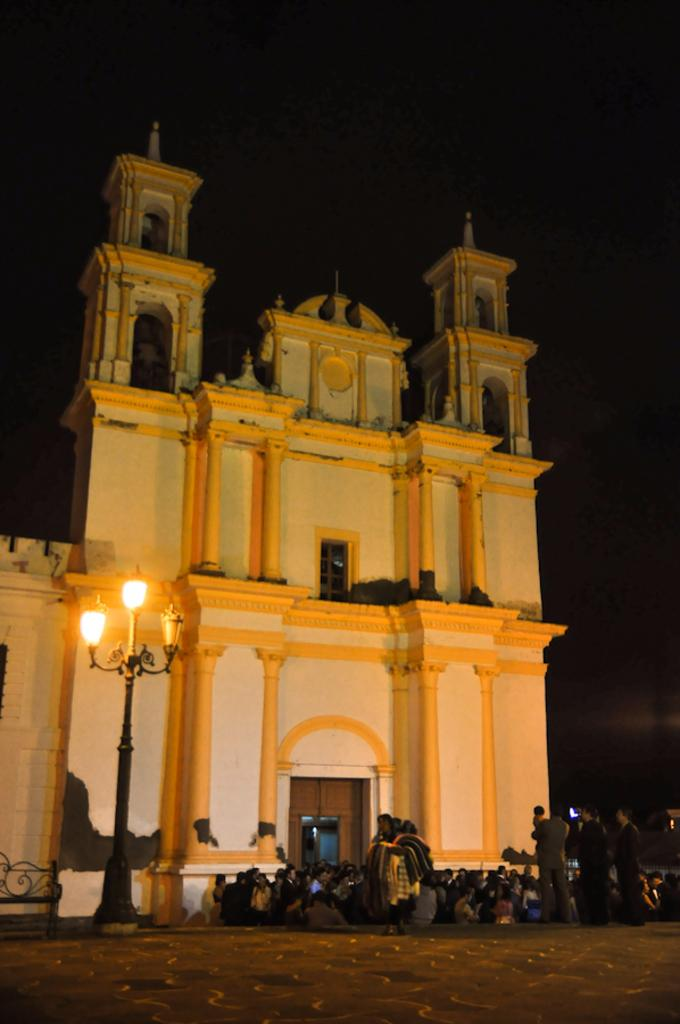What type of structure is visible in the image? There is a building in the image. Who or what else can be seen in the image? There are people standing in the image. What is located on the left side of the image? There is a pole with lights on the left side of the image. What is visible at the top of the image? The sky is visible at the top of the image. What type of skirt is the rainstorm wearing in the image? There is no rainstorm or skirt present in the image. What type of voyage are the people taking in the image? There is no indication of a voyage in the image; it simply shows a building, people, a pole with lights, and the sky. 